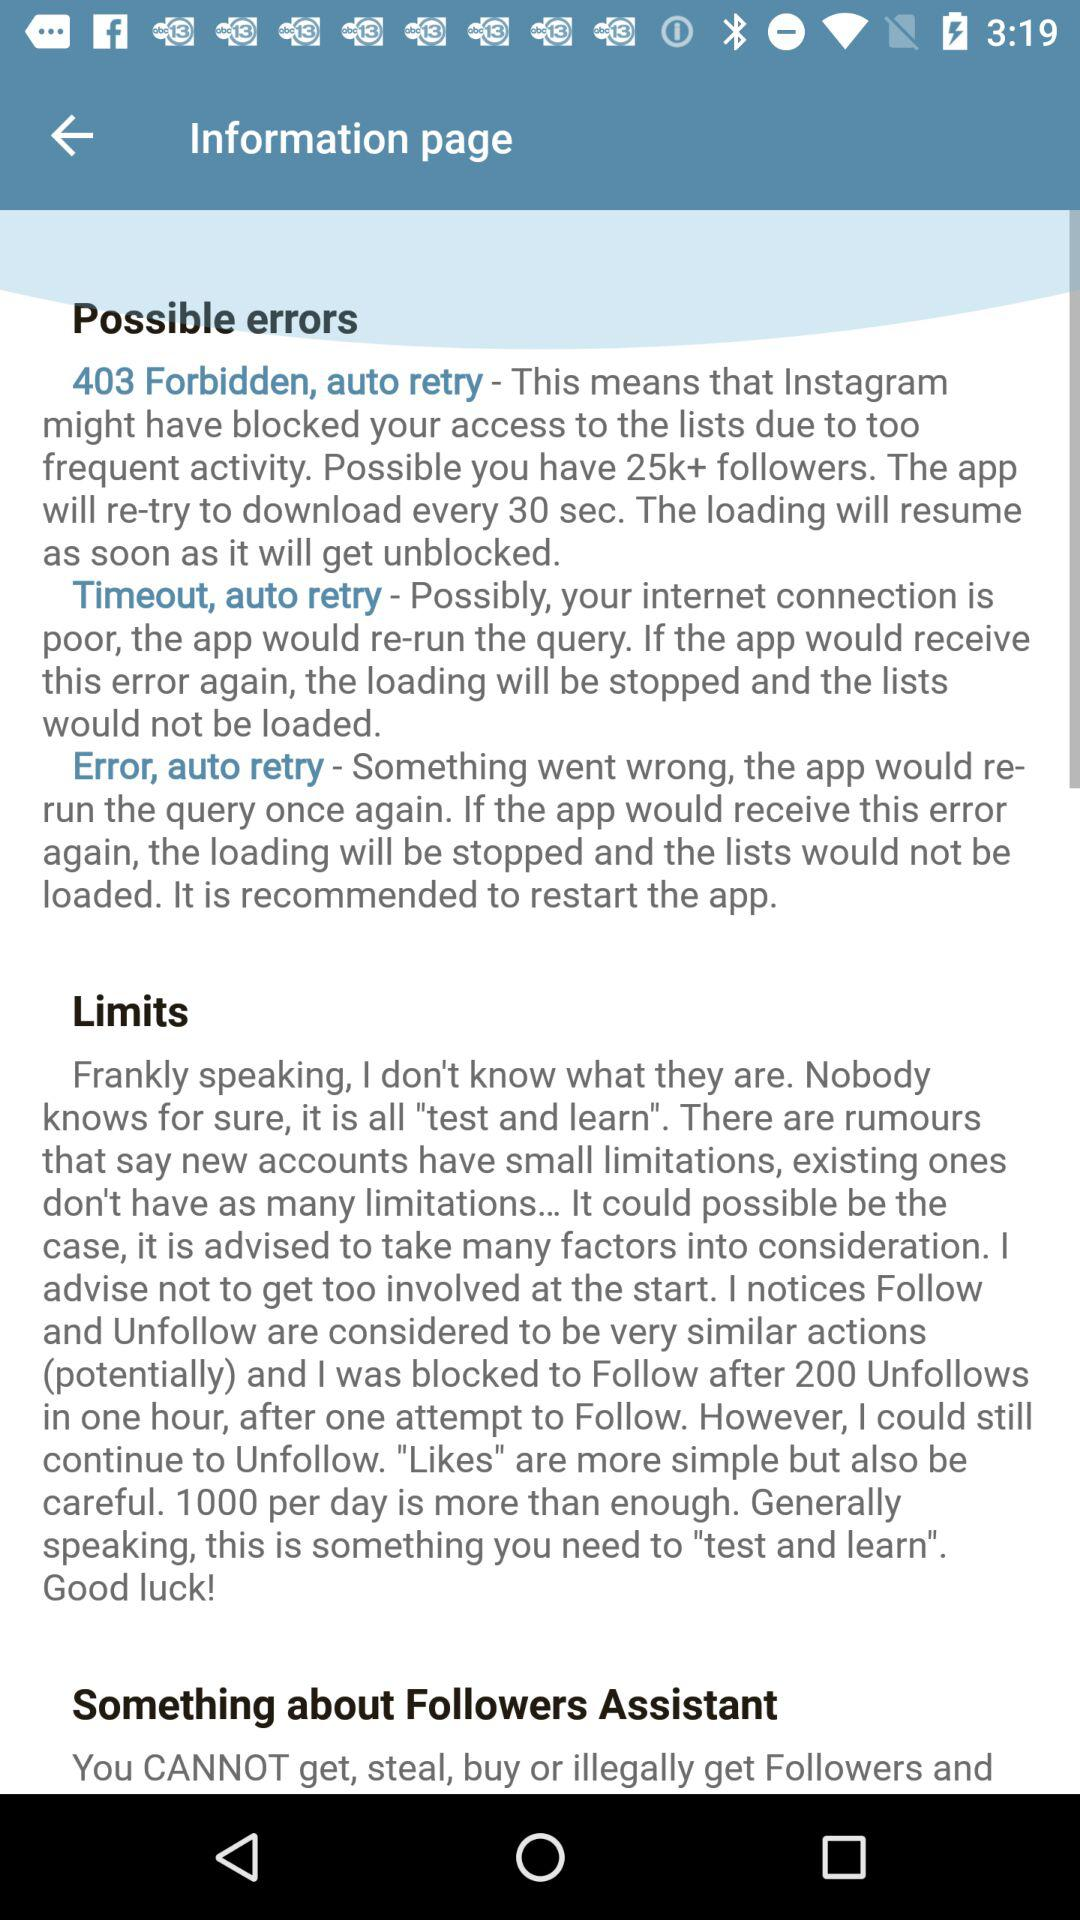How many possible errors are described in the information page?
Answer the question using a single word or phrase. 3 